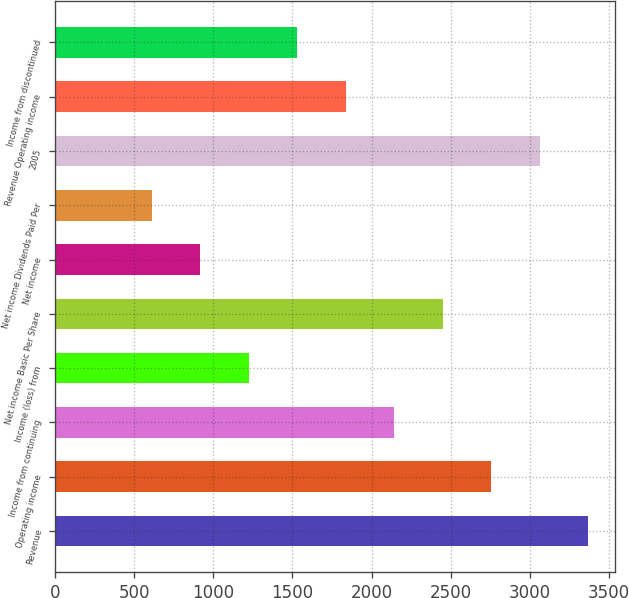<chart> <loc_0><loc_0><loc_500><loc_500><bar_chart><fcel>Revenue<fcel>Operating income<fcel>Income from continuing<fcel>Income (loss) from<fcel>Net income Basic Per Share<fcel>Net income<fcel>Net income Dividends Paid Per<fcel>2005<fcel>Revenue Operating income<fcel>Income from discontinued<nl><fcel>3369.33<fcel>2756.73<fcel>2144.13<fcel>1225.23<fcel>2450.43<fcel>918.93<fcel>612.63<fcel>3063.03<fcel>1837.83<fcel>1531.53<nl></chart> 